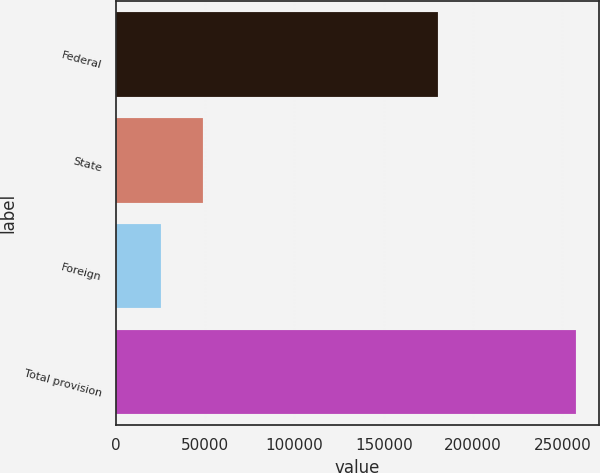Convert chart to OTSL. <chart><loc_0><loc_0><loc_500><loc_500><bar_chart><fcel>Federal<fcel>State<fcel>Foreign<fcel>Total provision<nl><fcel>180351<fcel>48721.8<fcel>25529<fcel>257457<nl></chart> 